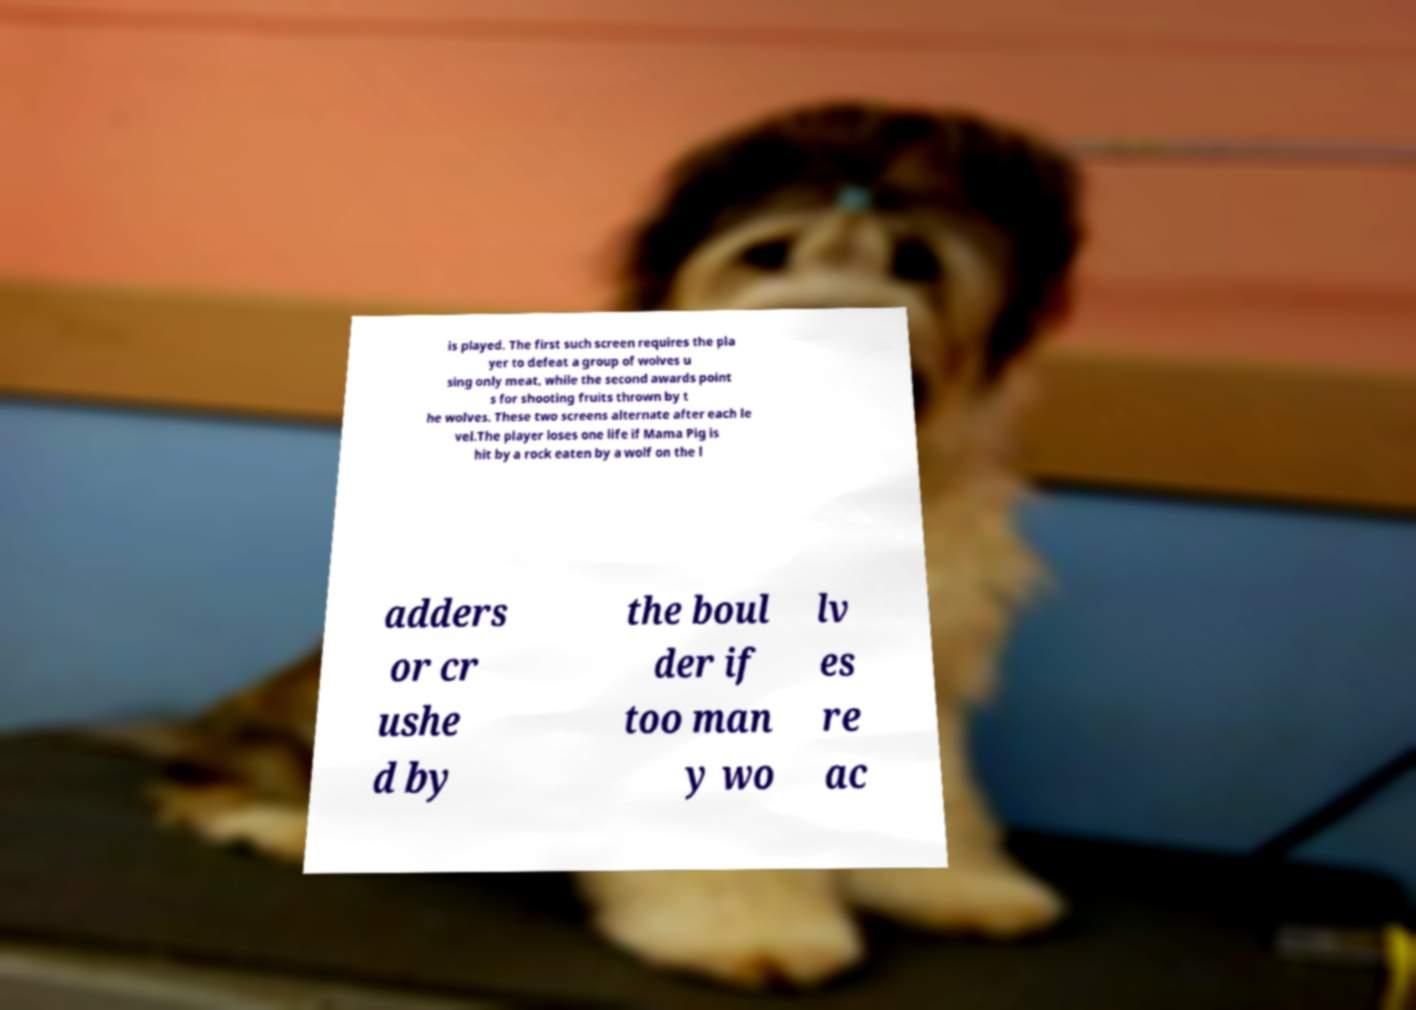Please read and relay the text visible in this image. What does it say? is played. The first such screen requires the pla yer to defeat a group of wolves u sing only meat, while the second awards point s for shooting fruits thrown by t he wolves. These two screens alternate after each le vel.The player loses one life if Mama Pig is hit by a rock eaten by a wolf on the l adders or cr ushe d by the boul der if too man y wo lv es re ac 